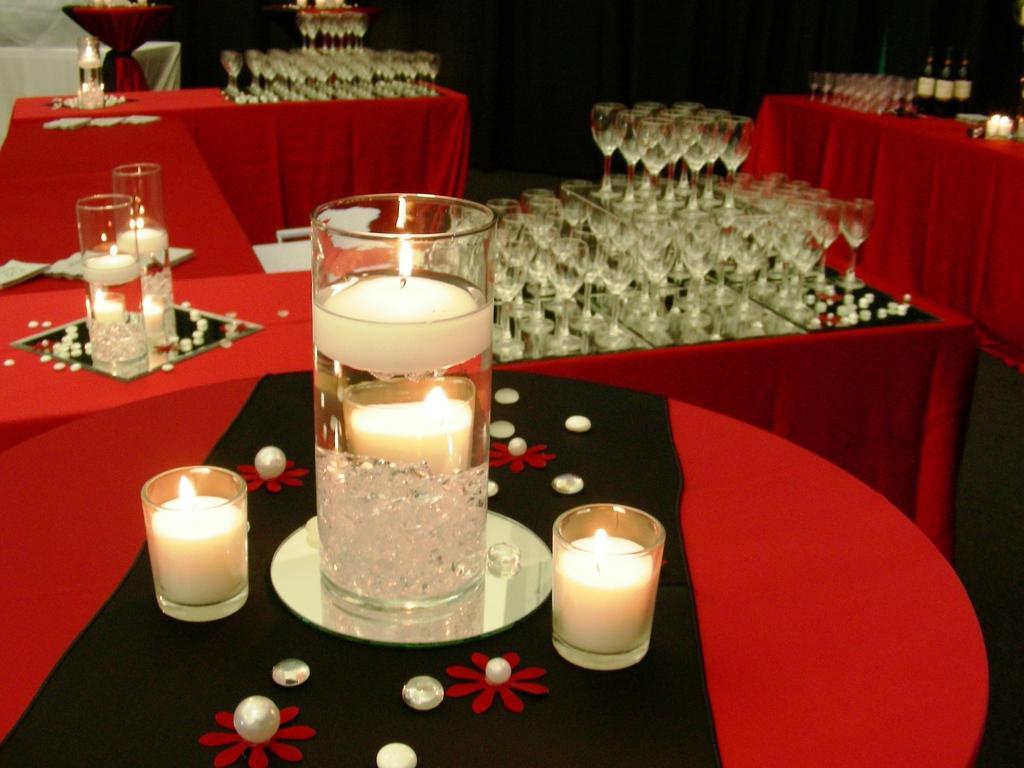Could you give a brief overview of what you see in this image? In this picture I can see decorative candles on the table. I can see a number of wine glasses on the table. I can see alcohol bottles on the right side. 